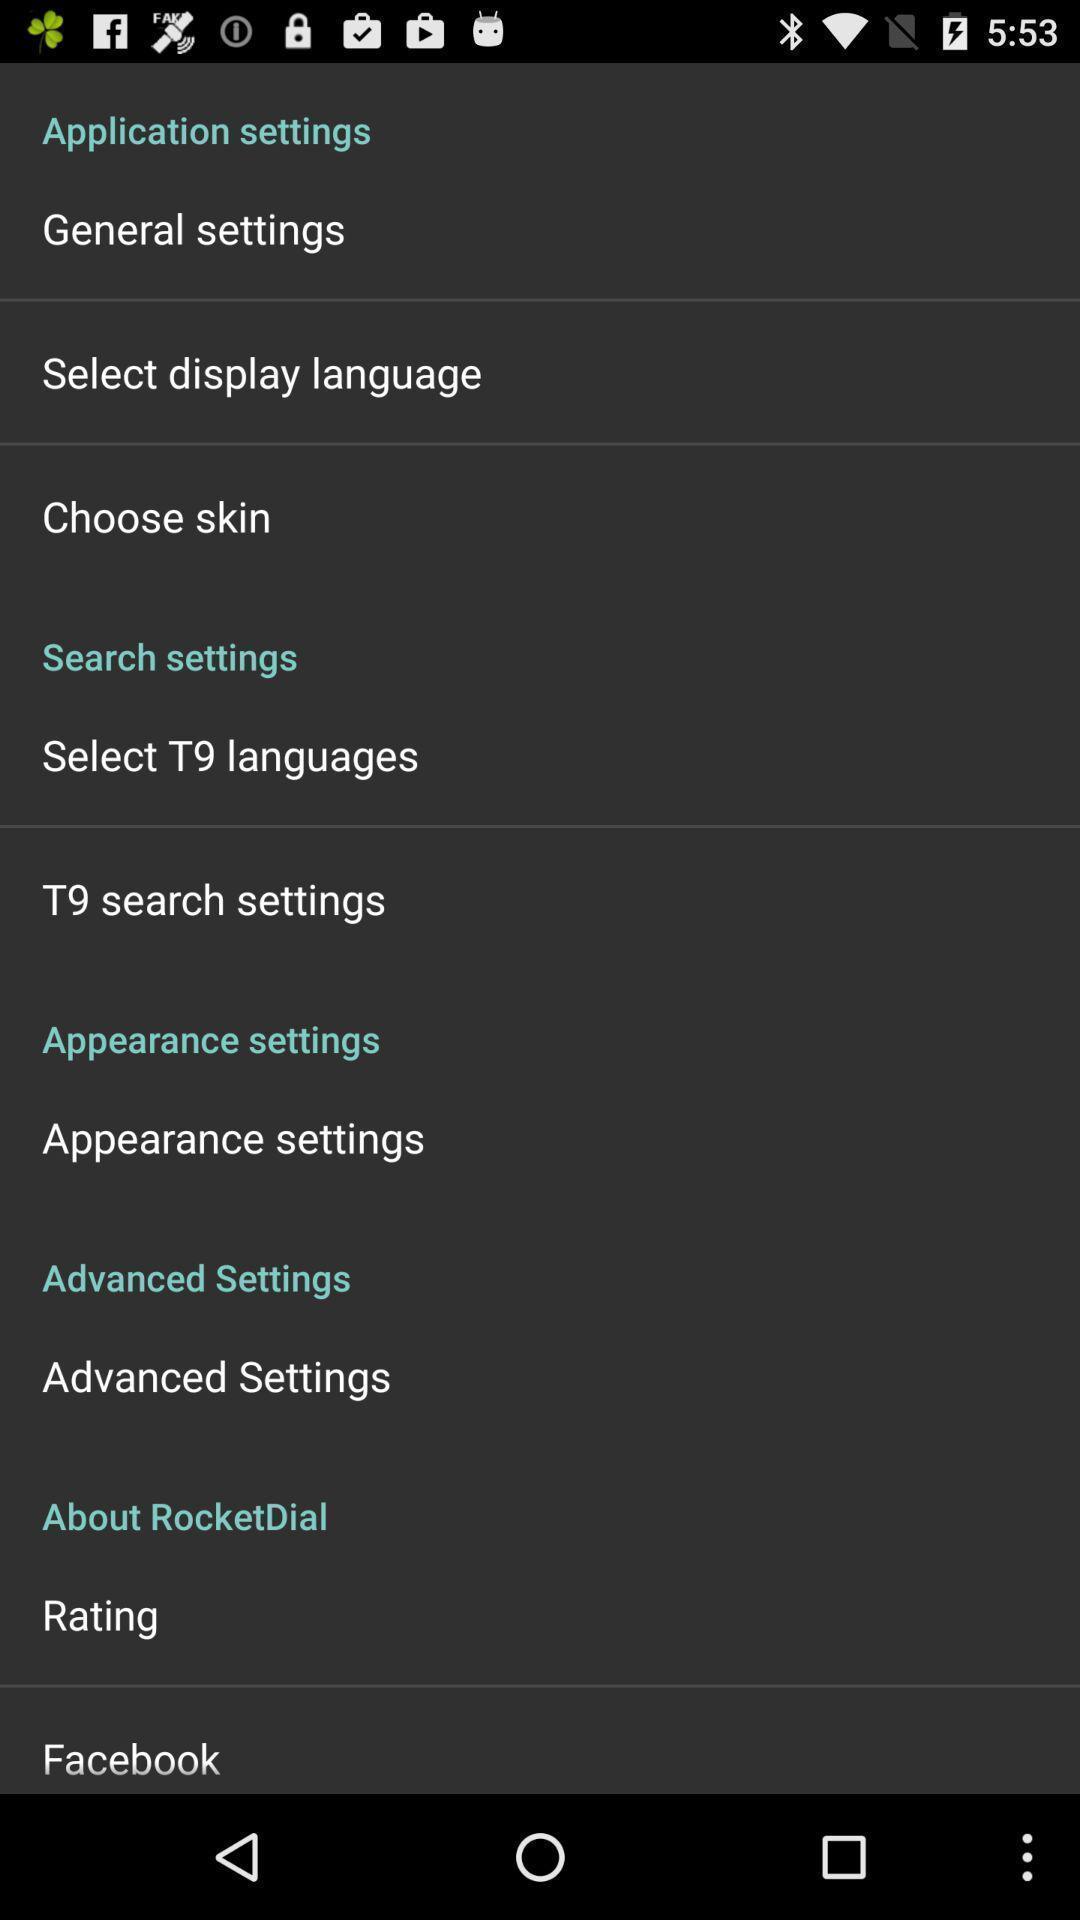What can you discern from this picture? Screen displaying the settings page. 